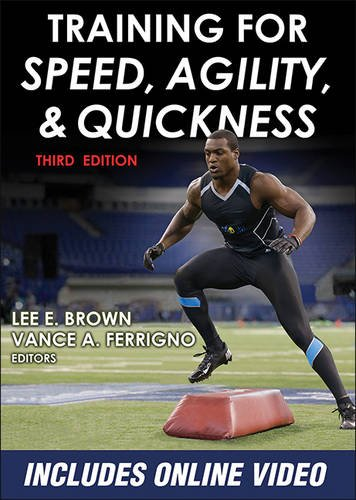Is this a fitness book? Yes, this is undoubtedly a fitness book, designed to assist in the development of key physical competencies such as speed, agility, and quickness, essential for high performance in sports. 